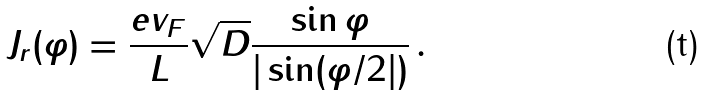Convert formula to latex. <formula><loc_0><loc_0><loc_500><loc_500>J _ { r } ( \varphi ) = \frac { e v _ { F } } { L } \sqrt { D } \frac { \sin \varphi } { | \sin ( \varphi / 2 | ) } \, .</formula> 